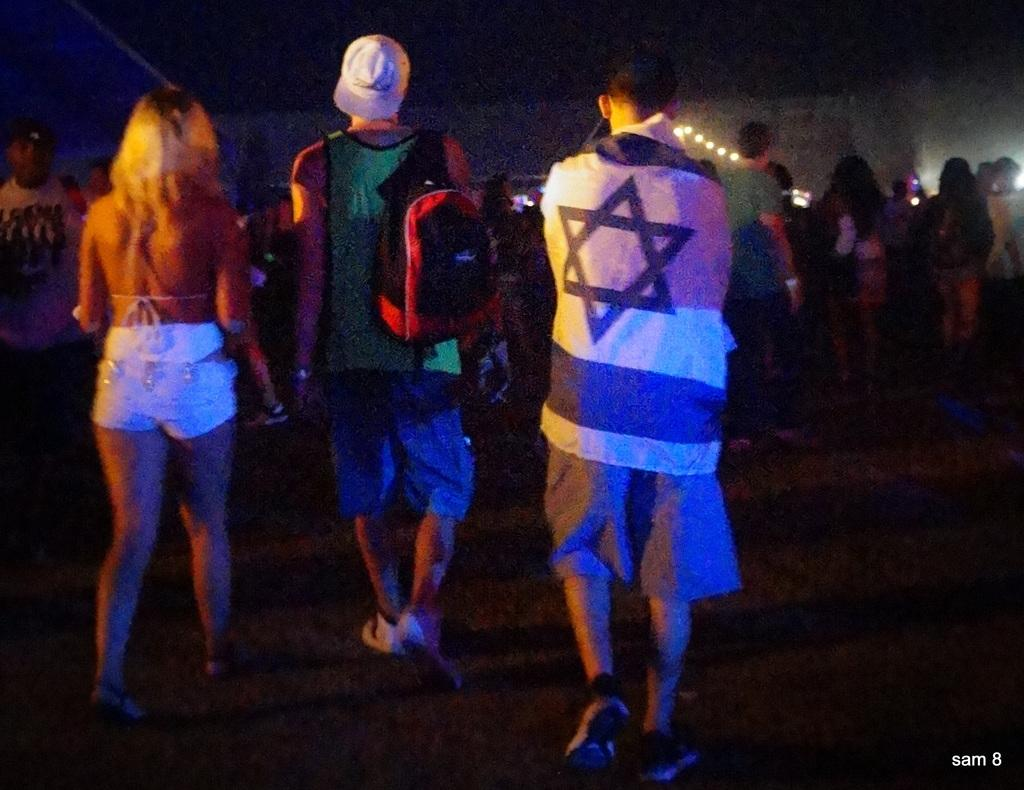How many people are present in the image? There are people in the image, but the exact number is not specified. What are some people wearing in the image? Some people are wearing bags and caps in the image. What can be seen at the bottom of the image? There is ground visible at the bottom of the image. What is written or depicted at the bottom of the image? There is text at the bottom of the image. What is visible at the top of the image? There are lights at the top of the image. What type of can is being used to hold the tray in the image? There is no can or tray present in the image. How many bikes are visible in the image? There is no mention of bikes in the image, so it is impossible to determine their number. 